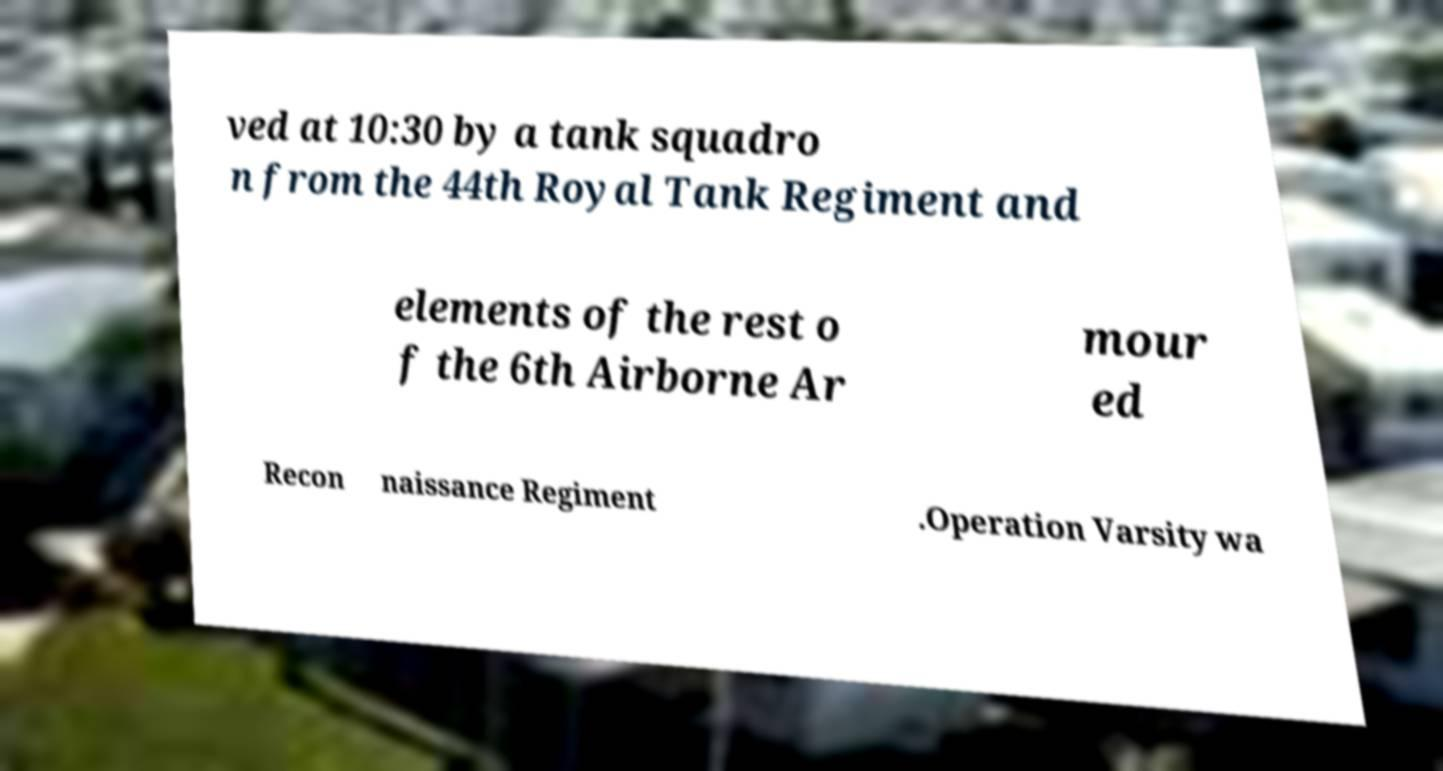What messages or text are displayed in this image? I need them in a readable, typed format. ved at 10:30 by a tank squadro n from the 44th Royal Tank Regiment and elements of the rest o f the 6th Airborne Ar mour ed Recon naissance Regiment .Operation Varsity wa 